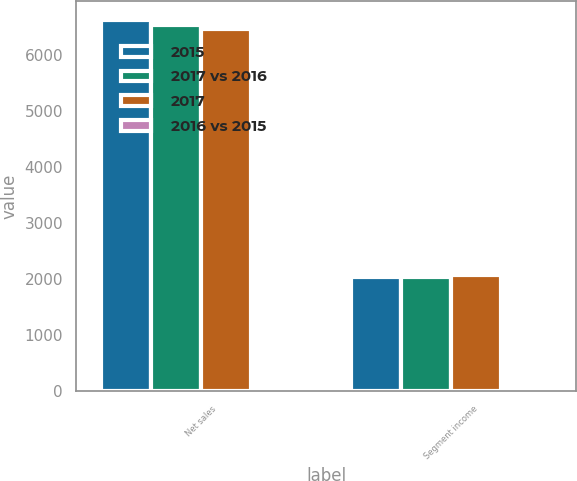Convert chart. <chart><loc_0><loc_0><loc_500><loc_500><stacked_bar_chart><ecel><fcel>Net sales<fcel>Segment income<nl><fcel>2015<fcel>6621.2<fcel>2045.6<nl><fcel>2017 vs 2016<fcel>6533<fcel>2041<nl><fcel>2017<fcel>6468.1<fcel>2074<nl><fcel>2016 vs 2015<fcel>1.3<fcel>0.2<nl></chart> 